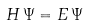Convert formula to latex. <formula><loc_0><loc_0><loc_500><loc_500>H \, \Psi = E \, \Psi</formula> 